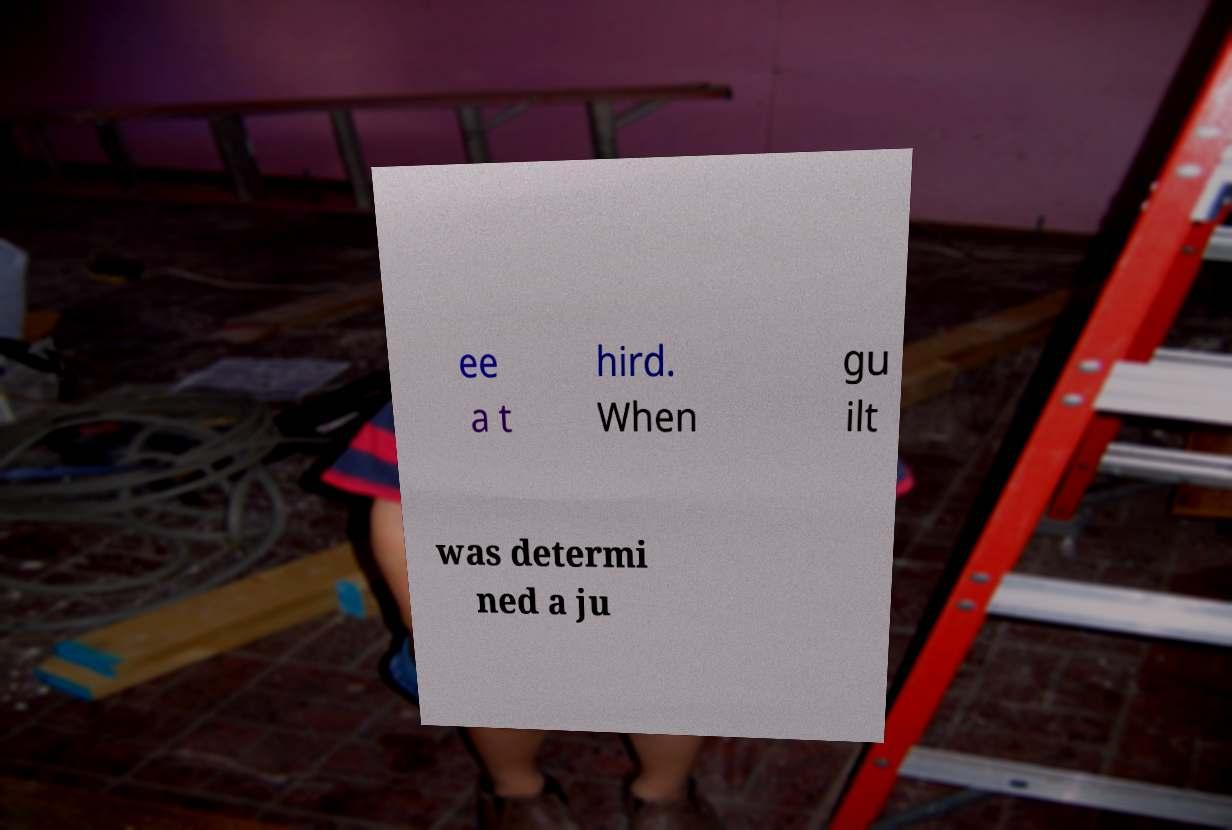For documentation purposes, I need the text within this image transcribed. Could you provide that? ee a t hird. When gu ilt was determi ned a ju 